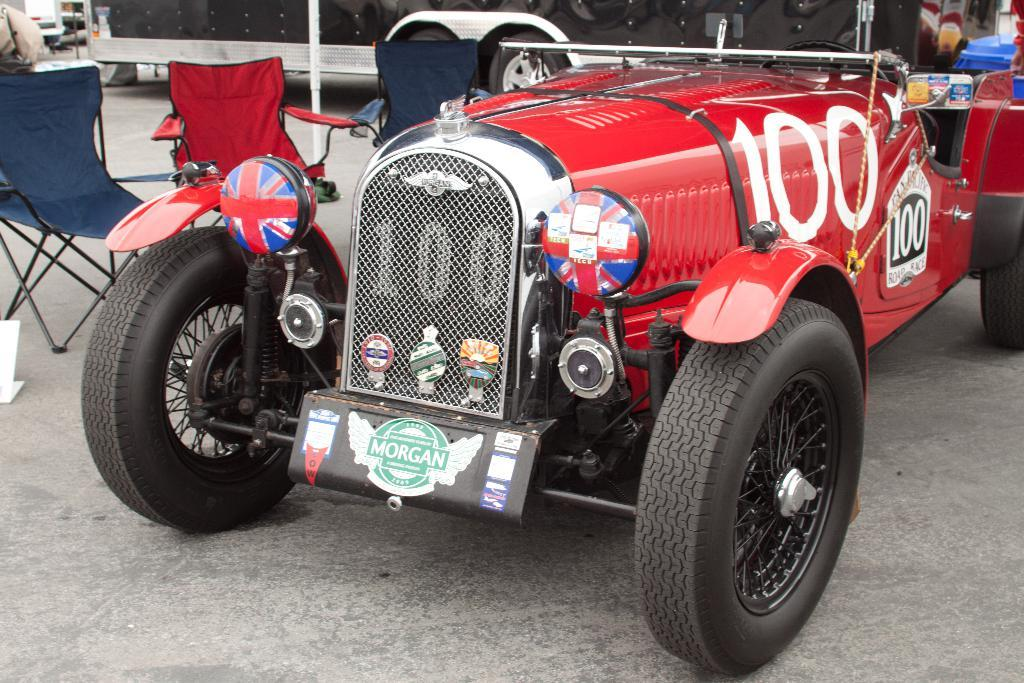What types of objects can be seen in the image? There are vehicles and chairs in the image. Can you describe the vehicles in the image? The provided facts do not specify the type of vehicles in the image. How are the chairs arranged in the image? The chairs are placed on the ground in the image. What type of tax is being discussed in the image? There is no discussion of tax in the image; it features vehicles and chairs. Is there a crook present in the image? There is no mention of a crook or any criminal activity in the image. 